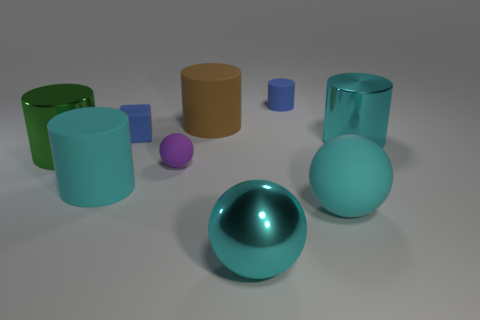Are there more big balls than big shiny spheres?
Provide a short and direct response. Yes. What number of small objects are green metal objects or cyan things?
Provide a succinct answer. 0. What number of other things are there of the same color as the large metallic sphere?
Provide a short and direct response. 3. What number of big cyan things are made of the same material as the tiny cylinder?
Offer a terse response. 2. Do the large rubber object to the right of the cyan shiny ball and the tiny cylinder have the same color?
Make the answer very short. No. What number of yellow things are matte spheres or metallic spheres?
Keep it short and to the point. 0. Is there any other thing that is the same material as the tiny purple ball?
Give a very brief answer. Yes. Are the large cyan cylinder to the right of the blue rubber cube and the blue cylinder made of the same material?
Your answer should be compact. No. How many objects are either cyan matte cylinders or balls on the left side of the small matte cylinder?
Your answer should be very brief. 3. What number of blue cubes are in front of the large matte cylinder behind the tiny purple ball in front of the cyan shiny cylinder?
Offer a very short reply. 1. 